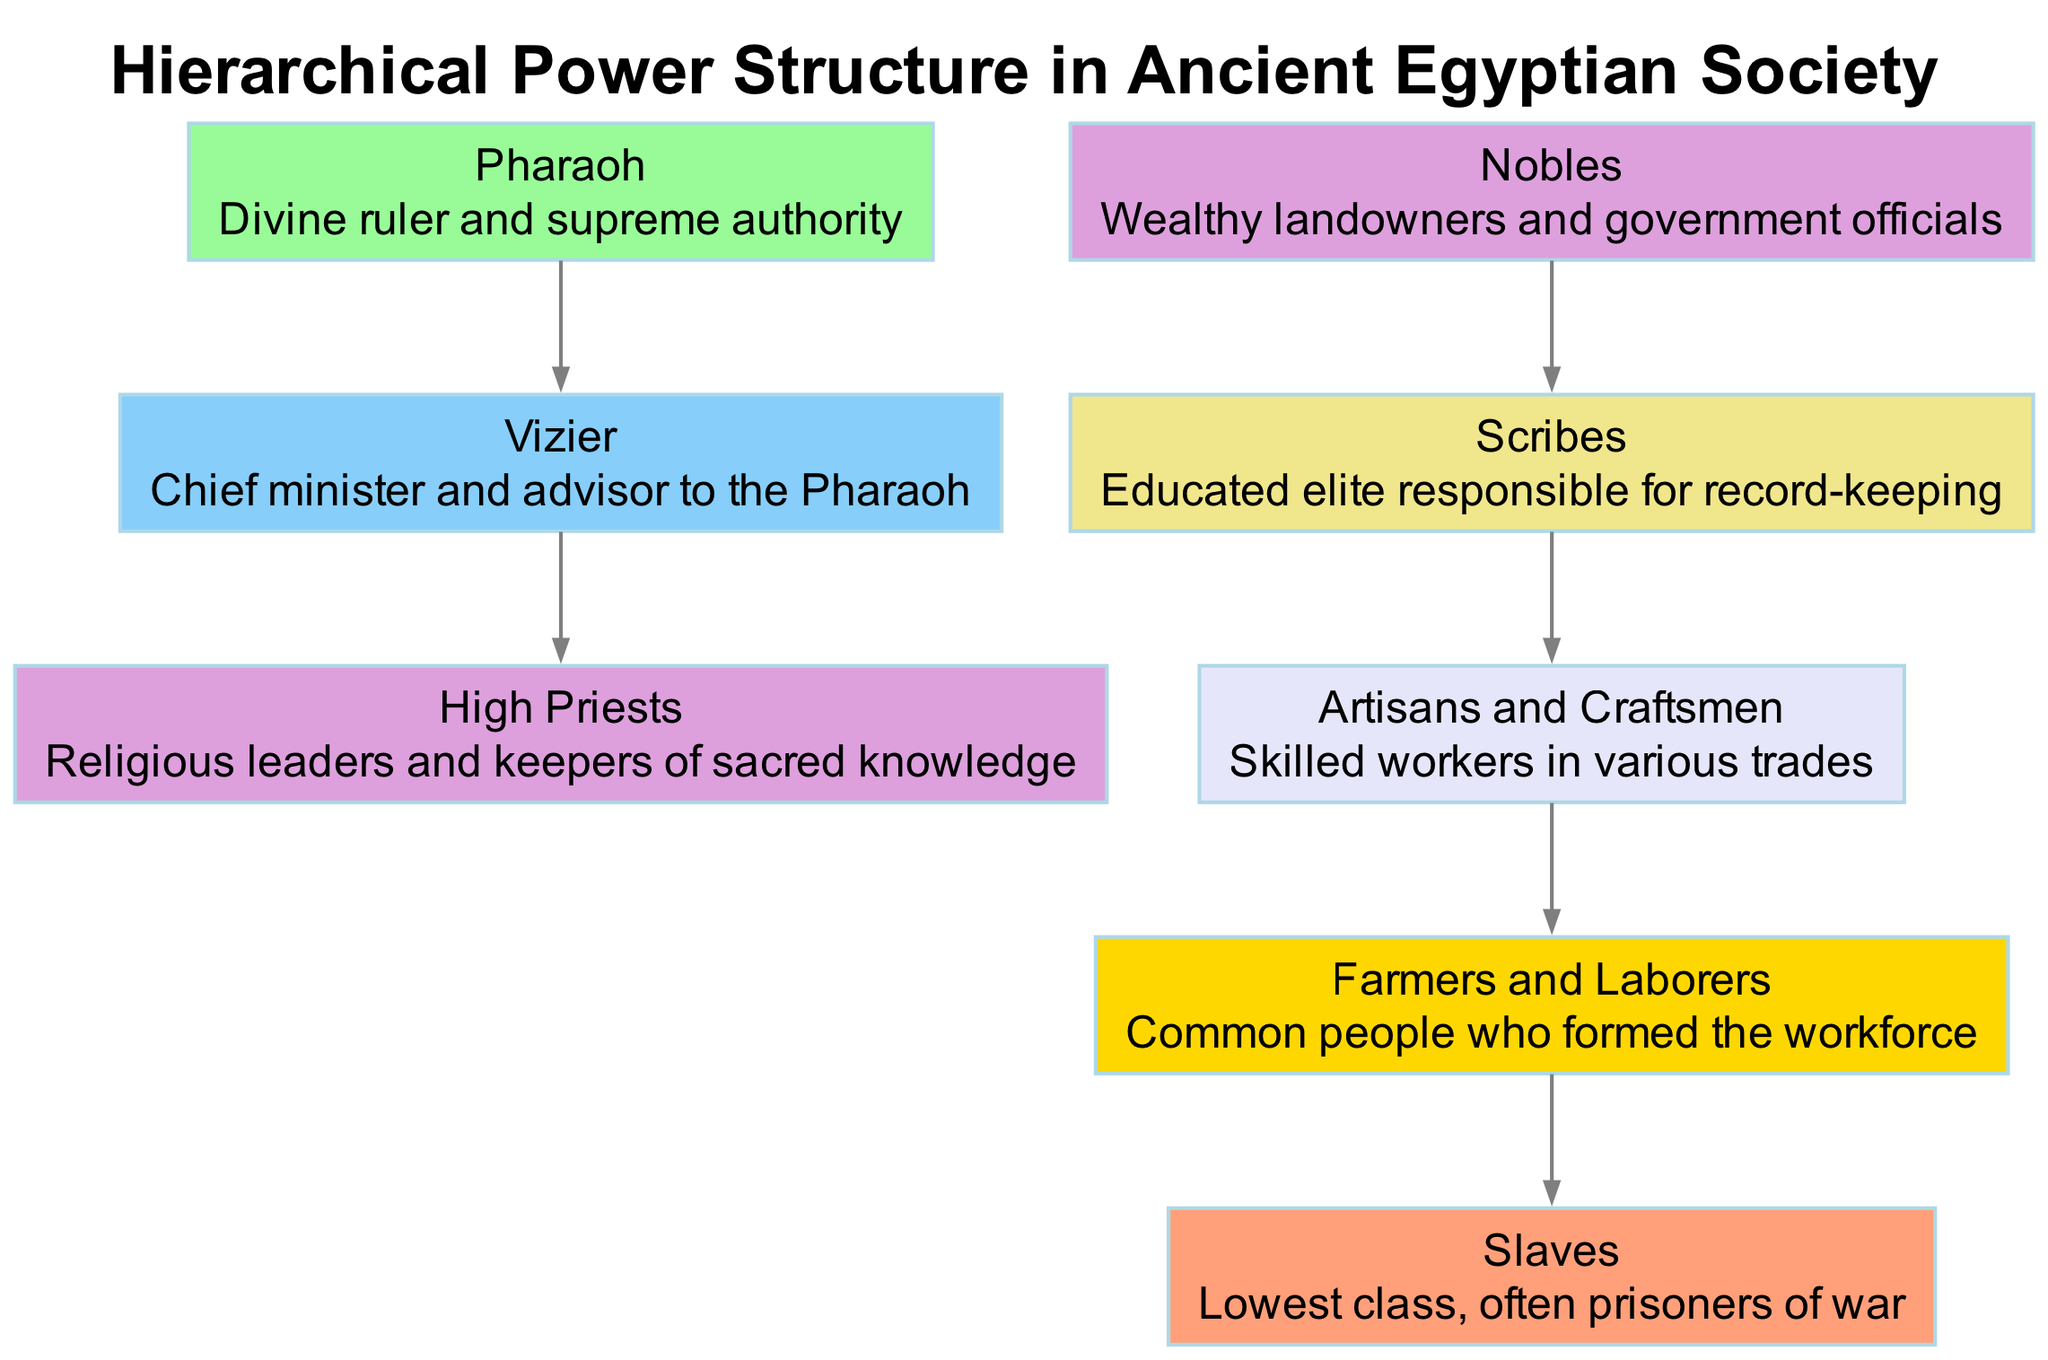What is the highest level in the hierarchy? The diagram indicates that the highest level in the hierarchy is the Pharaoh, as it is the first node listed and no nodes are higher.
Answer: Pharaoh How many levels are present in the structure? There are 7 distinct levels shown in the diagram, represented by the ascending levels of the nodes from Pharaoh down to Slaves.
Answer: 7 Who is directly below the Pharaoh? The Vizier is depicted directly below the Pharaoh in the hierarchy, indicating their role as the chief minister and advisor.
Answer: Vizier What role do Farmers and Laborers have in the society? Farmers and Laborers are positioned at the bottom level of the society's hierarchy, serving as the common workforce essential for agriculture and labor.
Answer: Common workforce Which class is considered the lowest in the hierarchy? Slaves are represented as the lowest class in the hierarchy, denoted as prisoners of war or the least privileged in society.
Answer: Slaves What relationship exists between High Priests and Nobles? Both High Priests and Nobles are on the same hierarchical level, indicating they hold similar status within the society but in different domains (religious and political).
Answer: Same level What is the function of Scribes in ancient Egyptian society? Scribes serve as the educated elite responsible for record-keeping, which is crucial for administration and management.
Answer: Record-keeping How many different classes are above the Farmers and Laborers? There are 4 classes above the Farmers and Laborers in the hierarchy, which include Artisans and Craftsmen, Scribes, Nobles, and High Priests.
Answer: 4 What color represents the Nobles in the diagram? The Nobles node is represented in a color signifying its level, which is a pastel shade due to being on the third level of hierarchy.
Answer: Light blue 